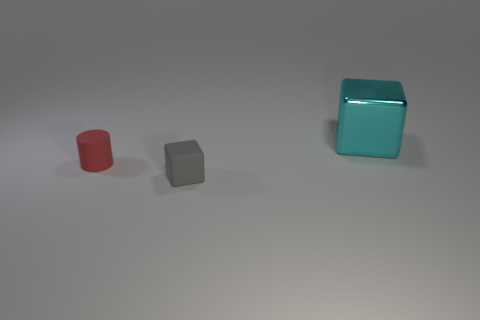Add 2 small red matte objects. How many objects exist? 5 Subtract all cylinders. How many objects are left? 2 Subtract all big red metallic balls. Subtract all cyan metallic objects. How many objects are left? 2 Add 2 tiny cubes. How many tiny cubes are left? 3 Add 2 tiny rubber cubes. How many tiny rubber cubes exist? 3 Subtract 0 red balls. How many objects are left? 3 